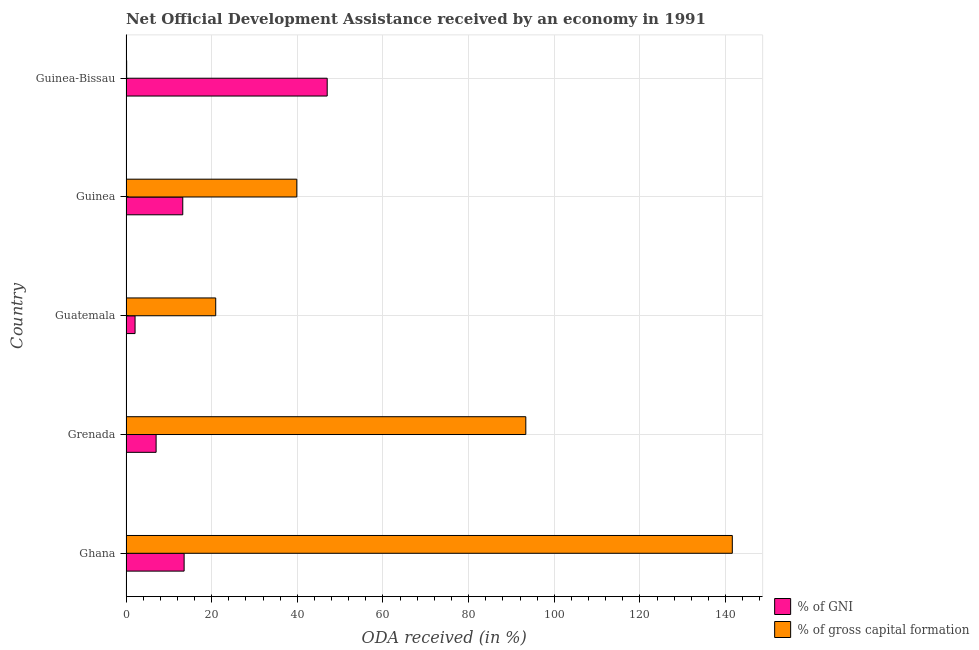How many different coloured bars are there?
Provide a succinct answer. 2. Are the number of bars on each tick of the Y-axis equal?
Offer a terse response. Yes. What is the label of the 3rd group of bars from the top?
Provide a short and direct response. Guatemala. In how many cases, is the number of bars for a given country not equal to the number of legend labels?
Your answer should be compact. 0. What is the oda received as percentage of gni in Grenada?
Ensure brevity in your answer.  7.03. Across all countries, what is the maximum oda received as percentage of gni?
Ensure brevity in your answer.  46.98. Across all countries, what is the minimum oda received as percentage of gni?
Make the answer very short. 2.11. In which country was the oda received as percentage of gni maximum?
Your answer should be very brief. Guinea-Bissau. In which country was the oda received as percentage of gni minimum?
Keep it short and to the point. Guatemala. What is the total oda received as percentage of gni in the graph?
Keep it short and to the point. 82.94. What is the difference between the oda received as percentage of gni in Ghana and that in Guinea?
Offer a terse response. 0.32. What is the difference between the oda received as percentage of gni in Grenada and the oda received as percentage of gross capital formation in Guinea?
Provide a short and direct response. -32.85. What is the average oda received as percentage of gni per country?
Provide a short and direct response. 16.59. What is the difference between the oda received as percentage of gross capital formation and oda received as percentage of gni in Guinea?
Your response must be concise. 26.63. What is the ratio of the oda received as percentage of gni in Grenada to that in Guinea?
Give a very brief answer. 0.53. What is the difference between the highest and the second highest oda received as percentage of gni?
Give a very brief answer. 33.41. What is the difference between the highest and the lowest oda received as percentage of gross capital formation?
Your response must be concise. 141.42. Is the sum of the oda received as percentage of gross capital formation in Grenada and Guinea-Bissau greater than the maximum oda received as percentage of gni across all countries?
Keep it short and to the point. Yes. What does the 1st bar from the top in Guinea-Bissau represents?
Your response must be concise. % of gross capital formation. What does the 1st bar from the bottom in Guinea-Bissau represents?
Ensure brevity in your answer.  % of GNI. Are all the bars in the graph horizontal?
Give a very brief answer. Yes. How many countries are there in the graph?
Ensure brevity in your answer.  5. Does the graph contain any zero values?
Offer a very short reply. No. How many legend labels are there?
Your response must be concise. 2. How are the legend labels stacked?
Your answer should be very brief. Vertical. What is the title of the graph?
Your answer should be very brief. Net Official Development Assistance received by an economy in 1991. Does "Secondary Education" appear as one of the legend labels in the graph?
Offer a terse response. No. What is the label or title of the X-axis?
Your answer should be compact. ODA received (in %). What is the label or title of the Y-axis?
Your answer should be compact. Country. What is the ODA received (in %) of % of GNI in Ghana?
Give a very brief answer. 13.57. What is the ODA received (in %) in % of gross capital formation in Ghana?
Provide a short and direct response. 141.57. What is the ODA received (in %) in % of GNI in Grenada?
Offer a terse response. 7.03. What is the ODA received (in %) in % of gross capital formation in Grenada?
Offer a very short reply. 93.36. What is the ODA received (in %) of % of GNI in Guatemala?
Keep it short and to the point. 2.11. What is the ODA received (in %) in % of gross capital formation in Guatemala?
Your answer should be very brief. 20.95. What is the ODA received (in %) in % of GNI in Guinea?
Offer a terse response. 13.25. What is the ODA received (in %) of % of gross capital formation in Guinea?
Offer a very short reply. 39.88. What is the ODA received (in %) of % of GNI in Guinea-Bissau?
Give a very brief answer. 46.98. What is the ODA received (in %) of % of gross capital formation in Guinea-Bissau?
Keep it short and to the point. 0.15. Across all countries, what is the maximum ODA received (in %) of % of GNI?
Make the answer very short. 46.98. Across all countries, what is the maximum ODA received (in %) of % of gross capital formation?
Make the answer very short. 141.57. Across all countries, what is the minimum ODA received (in %) in % of GNI?
Keep it short and to the point. 2.11. Across all countries, what is the minimum ODA received (in %) of % of gross capital formation?
Offer a very short reply. 0.15. What is the total ODA received (in %) of % of GNI in the graph?
Offer a very short reply. 82.94. What is the total ODA received (in %) in % of gross capital formation in the graph?
Ensure brevity in your answer.  295.91. What is the difference between the ODA received (in %) of % of GNI in Ghana and that in Grenada?
Your response must be concise. 6.54. What is the difference between the ODA received (in %) in % of gross capital formation in Ghana and that in Grenada?
Your answer should be compact. 48.22. What is the difference between the ODA received (in %) of % of GNI in Ghana and that in Guatemala?
Offer a terse response. 11.46. What is the difference between the ODA received (in %) of % of gross capital formation in Ghana and that in Guatemala?
Ensure brevity in your answer.  120.63. What is the difference between the ODA received (in %) in % of GNI in Ghana and that in Guinea?
Your response must be concise. 0.32. What is the difference between the ODA received (in %) of % of gross capital formation in Ghana and that in Guinea?
Offer a terse response. 101.69. What is the difference between the ODA received (in %) in % of GNI in Ghana and that in Guinea-Bissau?
Keep it short and to the point. -33.41. What is the difference between the ODA received (in %) of % of gross capital formation in Ghana and that in Guinea-Bissau?
Provide a short and direct response. 141.42. What is the difference between the ODA received (in %) of % of GNI in Grenada and that in Guatemala?
Provide a succinct answer. 4.92. What is the difference between the ODA received (in %) of % of gross capital formation in Grenada and that in Guatemala?
Offer a very short reply. 72.41. What is the difference between the ODA received (in %) of % of GNI in Grenada and that in Guinea?
Keep it short and to the point. -6.22. What is the difference between the ODA received (in %) in % of gross capital formation in Grenada and that in Guinea?
Your answer should be compact. 53.47. What is the difference between the ODA received (in %) of % of GNI in Grenada and that in Guinea-Bissau?
Keep it short and to the point. -39.95. What is the difference between the ODA received (in %) in % of gross capital formation in Grenada and that in Guinea-Bissau?
Provide a short and direct response. 93.21. What is the difference between the ODA received (in %) of % of GNI in Guatemala and that in Guinea?
Your answer should be very brief. -11.14. What is the difference between the ODA received (in %) of % of gross capital formation in Guatemala and that in Guinea?
Offer a very short reply. -18.94. What is the difference between the ODA received (in %) in % of GNI in Guatemala and that in Guinea-Bissau?
Ensure brevity in your answer.  -44.87. What is the difference between the ODA received (in %) in % of gross capital formation in Guatemala and that in Guinea-Bissau?
Your answer should be very brief. 20.8. What is the difference between the ODA received (in %) of % of GNI in Guinea and that in Guinea-Bissau?
Provide a short and direct response. -33.73. What is the difference between the ODA received (in %) in % of gross capital formation in Guinea and that in Guinea-Bissau?
Your response must be concise. 39.73. What is the difference between the ODA received (in %) in % of GNI in Ghana and the ODA received (in %) in % of gross capital formation in Grenada?
Keep it short and to the point. -79.79. What is the difference between the ODA received (in %) in % of GNI in Ghana and the ODA received (in %) in % of gross capital formation in Guatemala?
Ensure brevity in your answer.  -7.38. What is the difference between the ODA received (in %) in % of GNI in Ghana and the ODA received (in %) in % of gross capital formation in Guinea?
Provide a succinct answer. -26.31. What is the difference between the ODA received (in %) in % of GNI in Ghana and the ODA received (in %) in % of gross capital formation in Guinea-Bissau?
Your answer should be compact. 13.42. What is the difference between the ODA received (in %) of % of GNI in Grenada and the ODA received (in %) of % of gross capital formation in Guatemala?
Your answer should be very brief. -13.92. What is the difference between the ODA received (in %) of % of GNI in Grenada and the ODA received (in %) of % of gross capital formation in Guinea?
Keep it short and to the point. -32.85. What is the difference between the ODA received (in %) in % of GNI in Grenada and the ODA received (in %) in % of gross capital formation in Guinea-Bissau?
Make the answer very short. 6.88. What is the difference between the ODA received (in %) in % of GNI in Guatemala and the ODA received (in %) in % of gross capital formation in Guinea?
Keep it short and to the point. -37.77. What is the difference between the ODA received (in %) in % of GNI in Guatemala and the ODA received (in %) in % of gross capital formation in Guinea-Bissau?
Your answer should be compact. 1.96. What is the difference between the ODA received (in %) of % of GNI in Guinea and the ODA received (in %) of % of gross capital formation in Guinea-Bissau?
Provide a short and direct response. 13.1. What is the average ODA received (in %) of % of GNI per country?
Your answer should be compact. 16.59. What is the average ODA received (in %) of % of gross capital formation per country?
Ensure brevity in your answer.  59.18. What is the difference between the ODA received (in %) of % of GNI and ODA received (in %) of % of gross capital formation in Ghana?
Your answer should be very brief. -128. What is the difference between the ODA received (in %) in % of GNI and ODA received (in %) in % of gross capital formation in Grenada?
Give a very brief answer. -86.33. What is the difference between the ODA received (in %) in % of GNI and ODA received (in %) in % of gross capital formation in Guatemala?
Make the answer very short. -18.83. What is the difference between the ODA received (in %) of % of GNI and ODA received (in %) of % of gross capital formation in Guinea?
Offer a very short reply. -26.63. What is the difference between the ODA received (in %) in % of GNI and ODA received (in %) in % of gross capital formation in Guinea-Bissau?
Keep it short and to the point. 46.83. What is the ratio of the ODA received (in %) of % of GNI in Ghana to that in Grenada?
Keep it short and to the point. 1.93. What is the ratio of the ODA received (in %) of % of gross capital formation in Ghana to that in Grenada?
Your response must be concise. 1.52. What is the ratio of the ODA received (in %) in % of GNI in Ghana to that in Guatemala?
Keep it short and to the point. 6.42. What is the ratio of the ODA received (in %) in % of gross capital formation in Ghana to that in Guatemala?
Offer a very short reply. 6.76. What is the ratio of the ODA received (in %) of % of GNI in Ghana to that in Guinea?
Offer a terse response. 1.02. What is the ratio of the ODA received (in %) of % of gross capital formation in Ghana to that in Guinea?
Offer a terse response. 3.55. What is the ratio of the ODA received (in %) in % of GNI in Ghana to that in Guinea-Bissau?
Give a very brief answer. 0.29. What is the ratio of the ODA received (in %) in % of gross capital formation in Ghana to that in Guinea-Bissau?
Keep it short and to the point. 940.01. What is the ratio of the ODA received (in %) in % of GNI in Grenada to that in Guatemala?
Your answer should be very brief. 3.33. What is the ratio of the ODA received (in %) in % of gross capital formation in Grenada to that in Guatemala?
Make the answer very short. 4.46. What is the ratio of the ODA received (in %) in % of GNI in Grenada to that in Guinea?
Give a very brief answer. 0.53. What is the ratio of the ODA received (in %) in % of gross capital formation in Grenada to that in Guinea?
Offer a very short reply. 2.34. What is the ratio of the ODA received (in %) in % of GNI in Grenada to that in Guinea-Bissau?
Your answer should be compact. 0.15. What is the ratio of the ODA received (in %) of % of gross capital formation in Grenada to that in Guinea-Bissau?
Offer a very short reply. 619.85. What is the ratio of the ODA received (in %) of % of GNI in Guatemala to that in Guinea?
Your answer should be very brief. 0.16. What is the ratio of the ODA received (in %) in % of gross capital formation in Guatemala to that in Guinea?
Provide a succinct answer. 0.53. What is the ratio of the ODA received (in %) of % of GNI in Guatemala to that in Guinea-Bissau?
Provide a short and direct response. 0.04. What is the ratio of the ODA received (in %) in % of gross capital formation in Guatemala to that in Guinea-Bissau?
Your answer should be compact. 139.07. What is the ratio of the ODA received (in %) in % of GNI in Guinea to that in Guinea-Bissau?
Your answer should be compact. 0.28. What is the ratio of the ODA received (in %) in % of gross capital formation in Guinea to that in Guinea-Bissau?
Make the answer very short. 264.8. What is the difference between the highest and the second highest ODA received (in %) of % of GNI?
Make the answer very short. 33.41. What is the difference between the highest and the second highest ODA received (in %) in % of gross capital formation?
Provide a short and direct response. 48.22. What is the difference between the highest and the lowest ODA received (in %) of % of GNI?
Provide a succinct answer. 44.87. What is the difference between the highest and the lowest ODA received (in %) of % of gross capital formation?
Give a very brief answer. 141.42. 